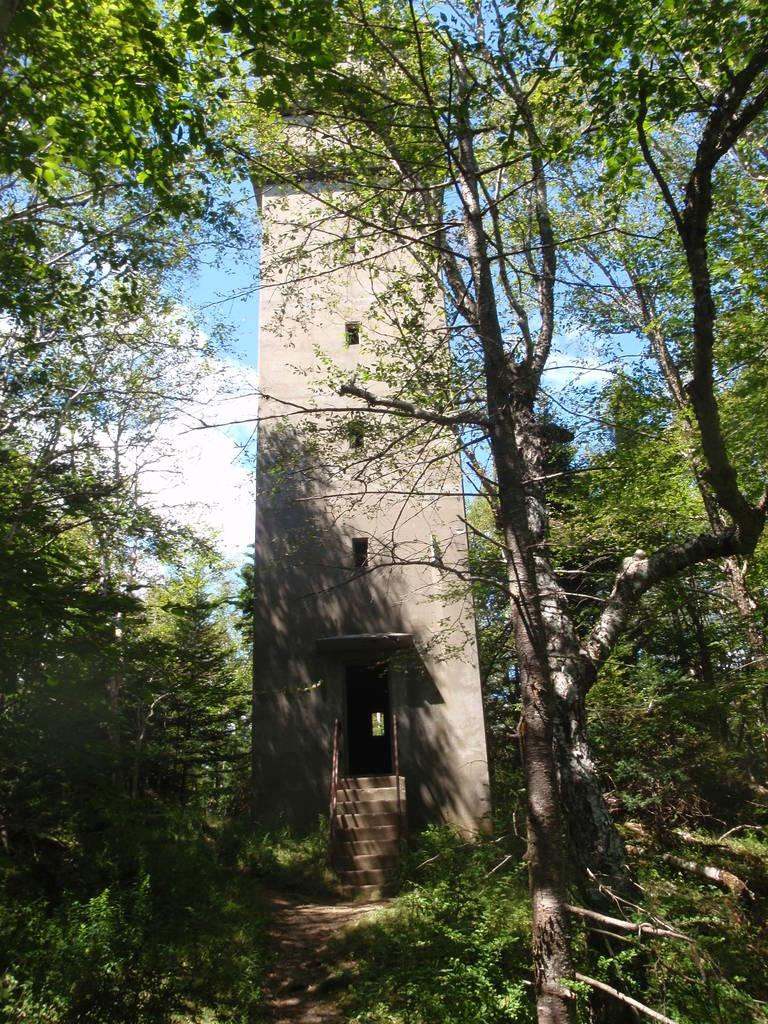What is the main structure visible in the image? There is a tower in the image. Where is the tower situated? The tower is located in a forest area. What type of song can be heard being sung by the sun in the image? There is no sun or singing in the image; it features a tower in a forest area. Where is the cellar located in the image? There is no cellar present in the image. 